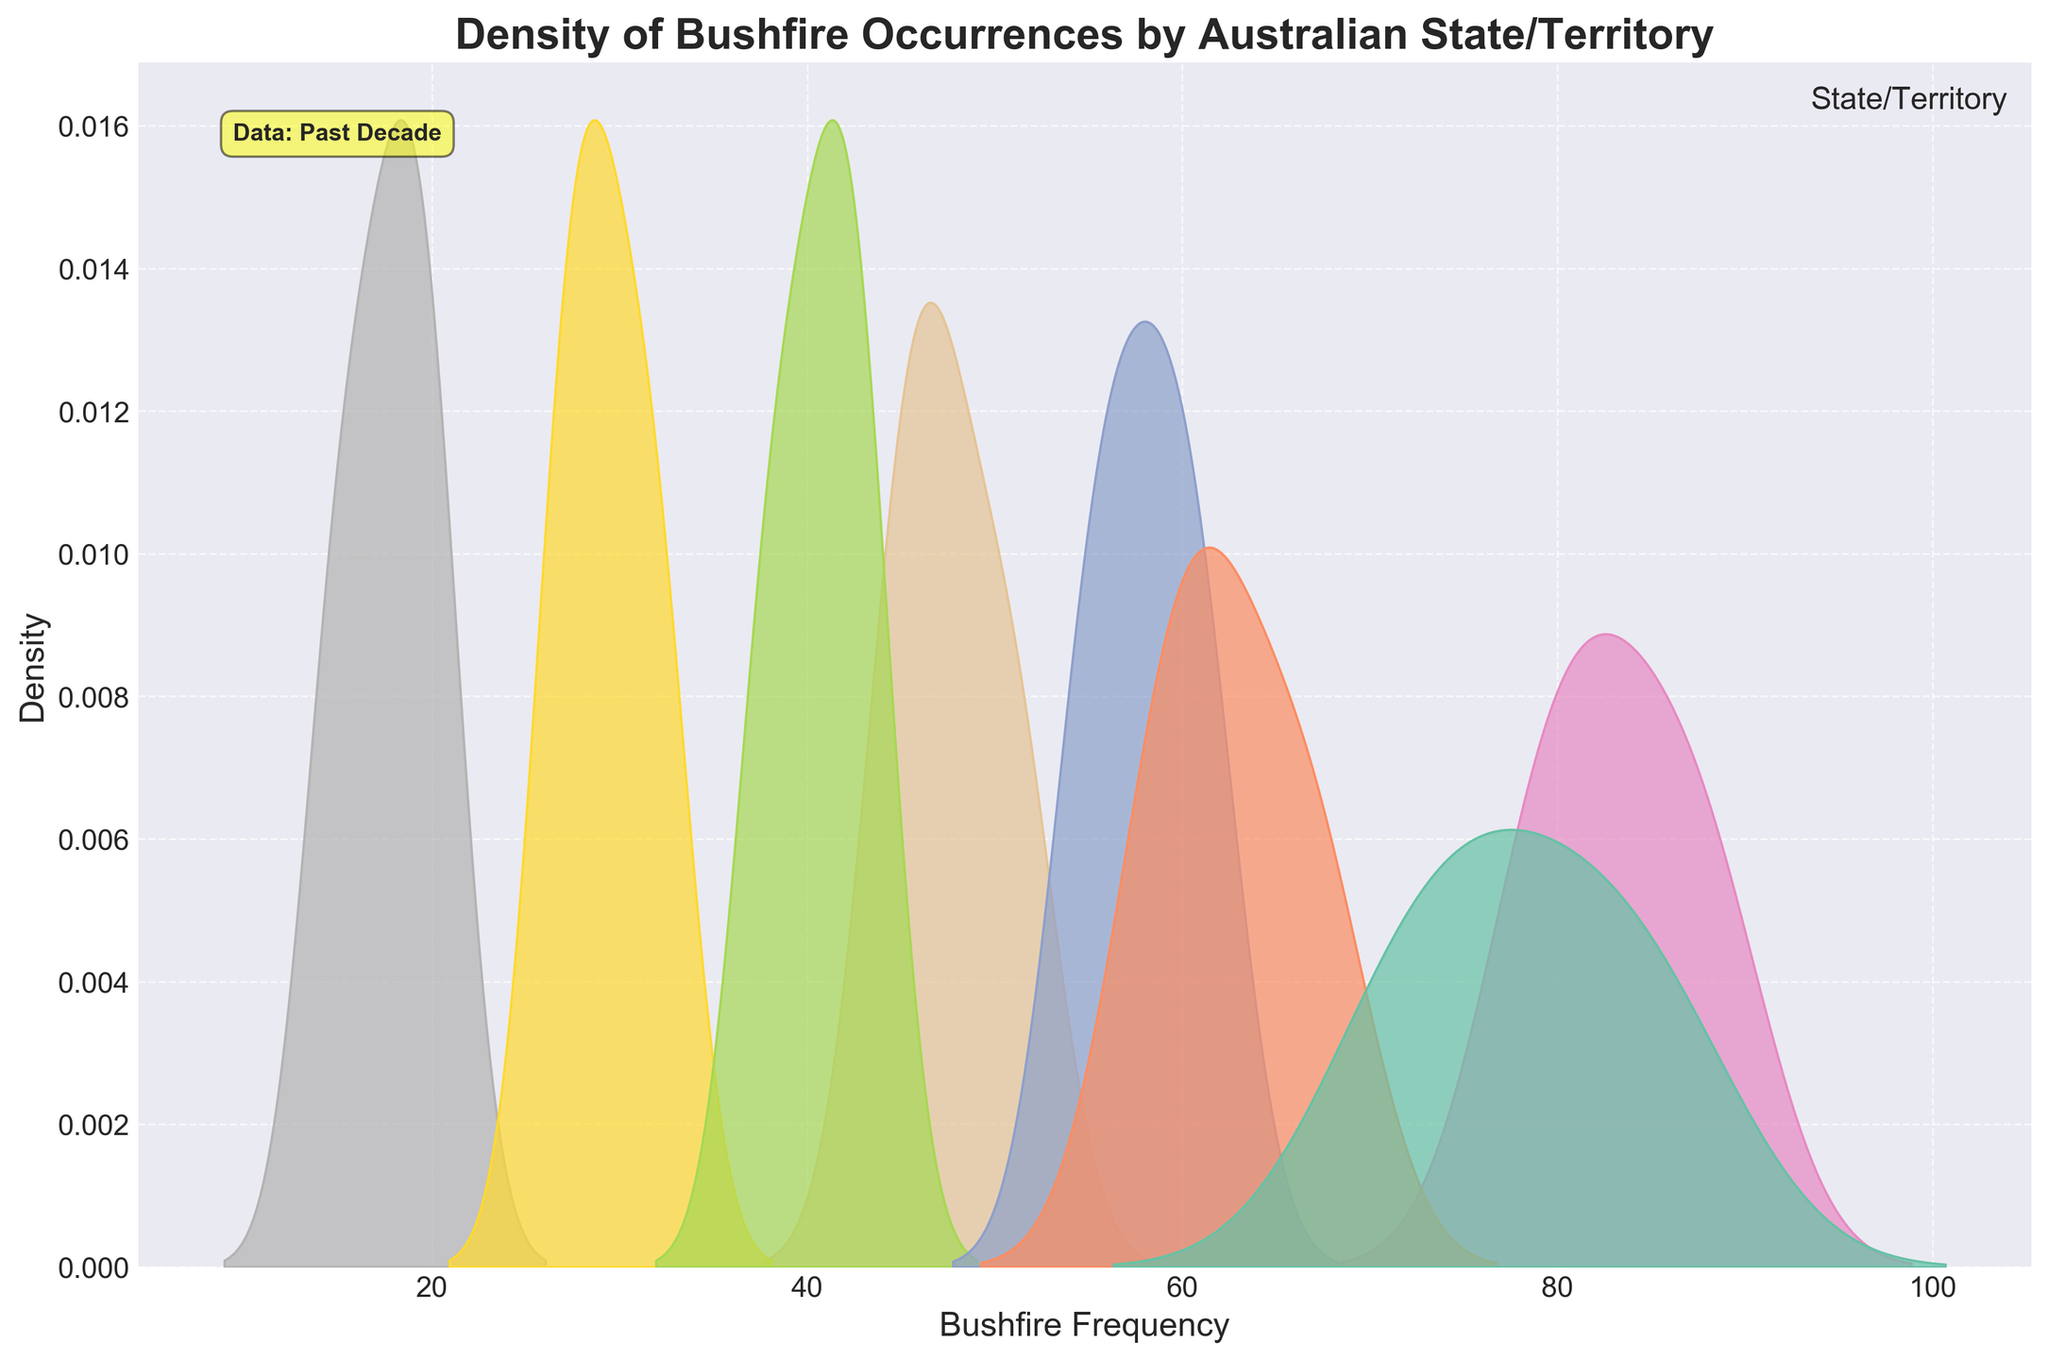What's the title of the figure? The title is usually displayed at the top of the figure. In this case, it is clearly written in a bold font.
Answer: Density of Bushfire Occurrences by Australian State/Territory What does the x-axis represent? The x-axis label is positioned below the axis and indicates what variable it represents. Here, it is labeled 'Bushfire Frequency'.
Answer: Bushfire Frequency Which state/territory has the highest density of bushfire frequencies? To determine this, look for the curve that reaches the highest point on the y-axis (density). Western Australia has the highest peak among all the states/territories.
Answer: Western Australia What color is used for Tasmania in the plot? Colors are allocated to each state/territory as shown in the legend. According to the legend, Tasmania is depicted in a specific color on the plot.
Answer: (Specific color as per Set2 palette, usually a shade of green or purple) Are there any states with similar bushfire frequency densities? By visually comparing the density curves, one can identify overlapping or closely situated curves. For instance, New South Wales and Western Australia show similar densities.
Answer: New South Wales and Western Australia Which state/territory has the lowest median bushfire frequency? The median is the point at which half the data falls below and half above. The curve with a peak that aligns closest to the left on the x-axis generally has a lower median value. Australian Capital Territory's peak suggests it has the lowest frequency values.
Answer: Australian Capital Territory What's the approximate range of bushfire frequency values for Queensland? The range can be estimated from where the Queensland density plot starts to where it ends on the x-axis.
Answer: Approximately 55 to 61 How does the bushfire frequency in Victoria compare with South Australia? By comparing the density plots for Victoria and South Australia, one can see that Victoria generally has higher bushfire frequencies than South Australia, as indicated by the position and height of the density peaks.
Answer: Victoria has higher frequencies Which state/territory shows a bimodal distribution? A bimodal distribution will have two distinct peaks in its density plot. Western Australia shows two peaks, indicating a bimodal distribution.
Answer: Western Australia 